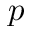<formula> <loc_0><loc_0><loc_500><loc_500>p</formula> 